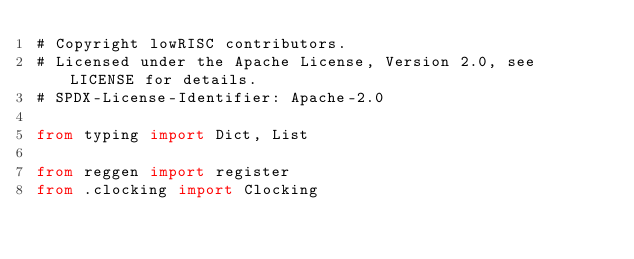<code> <loc_0><loc_0><loc_500><loc_500><_Python_># Copyright lowRISC contributors.
# Licensed under the Apache License, Version 2.0, see LICENSE for details.
# SPDX-License-Identifier: Apache-2.0

from typing import Dict, List

from reggen import register
from .clocking import Clocking</code> 